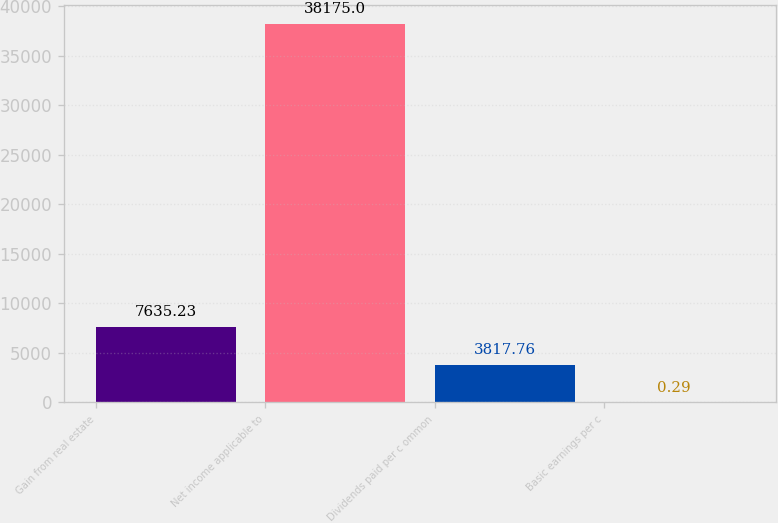Convert chart. <chart><loc_0><loc_0><loc_500><loc_500><bar_chart><fcel>Gain from real estate<fcel>Net income applicable to<fcel>Dividends paid per c ommon<fcel>Basic earnings per c<nl><fcel>7635.23<fcel>38175<fcel>3817.76<fcel>0.29<nl></chart> 